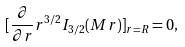<formula> <loc_0><loc_0><loc_500><loc_500>[ \frac { \partial } { \partial r } r ^ { 3 / 2 } I _ { 3 / 2 } ( M r ) ] _ { r = R } = 0 ,</formula> 